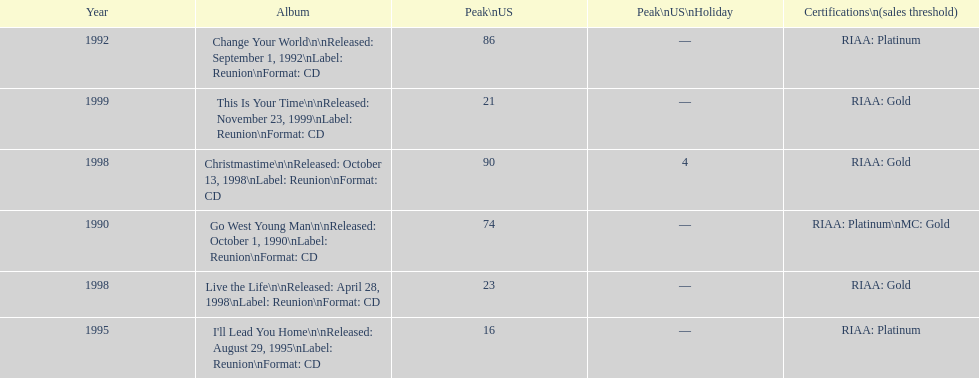Which album has the least peak in the us? I'll Lead You Home. 